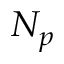Convert formula to latex. <formula><loc_0><loc_0><loc_500><loc_500>N _ { p }</formula> 